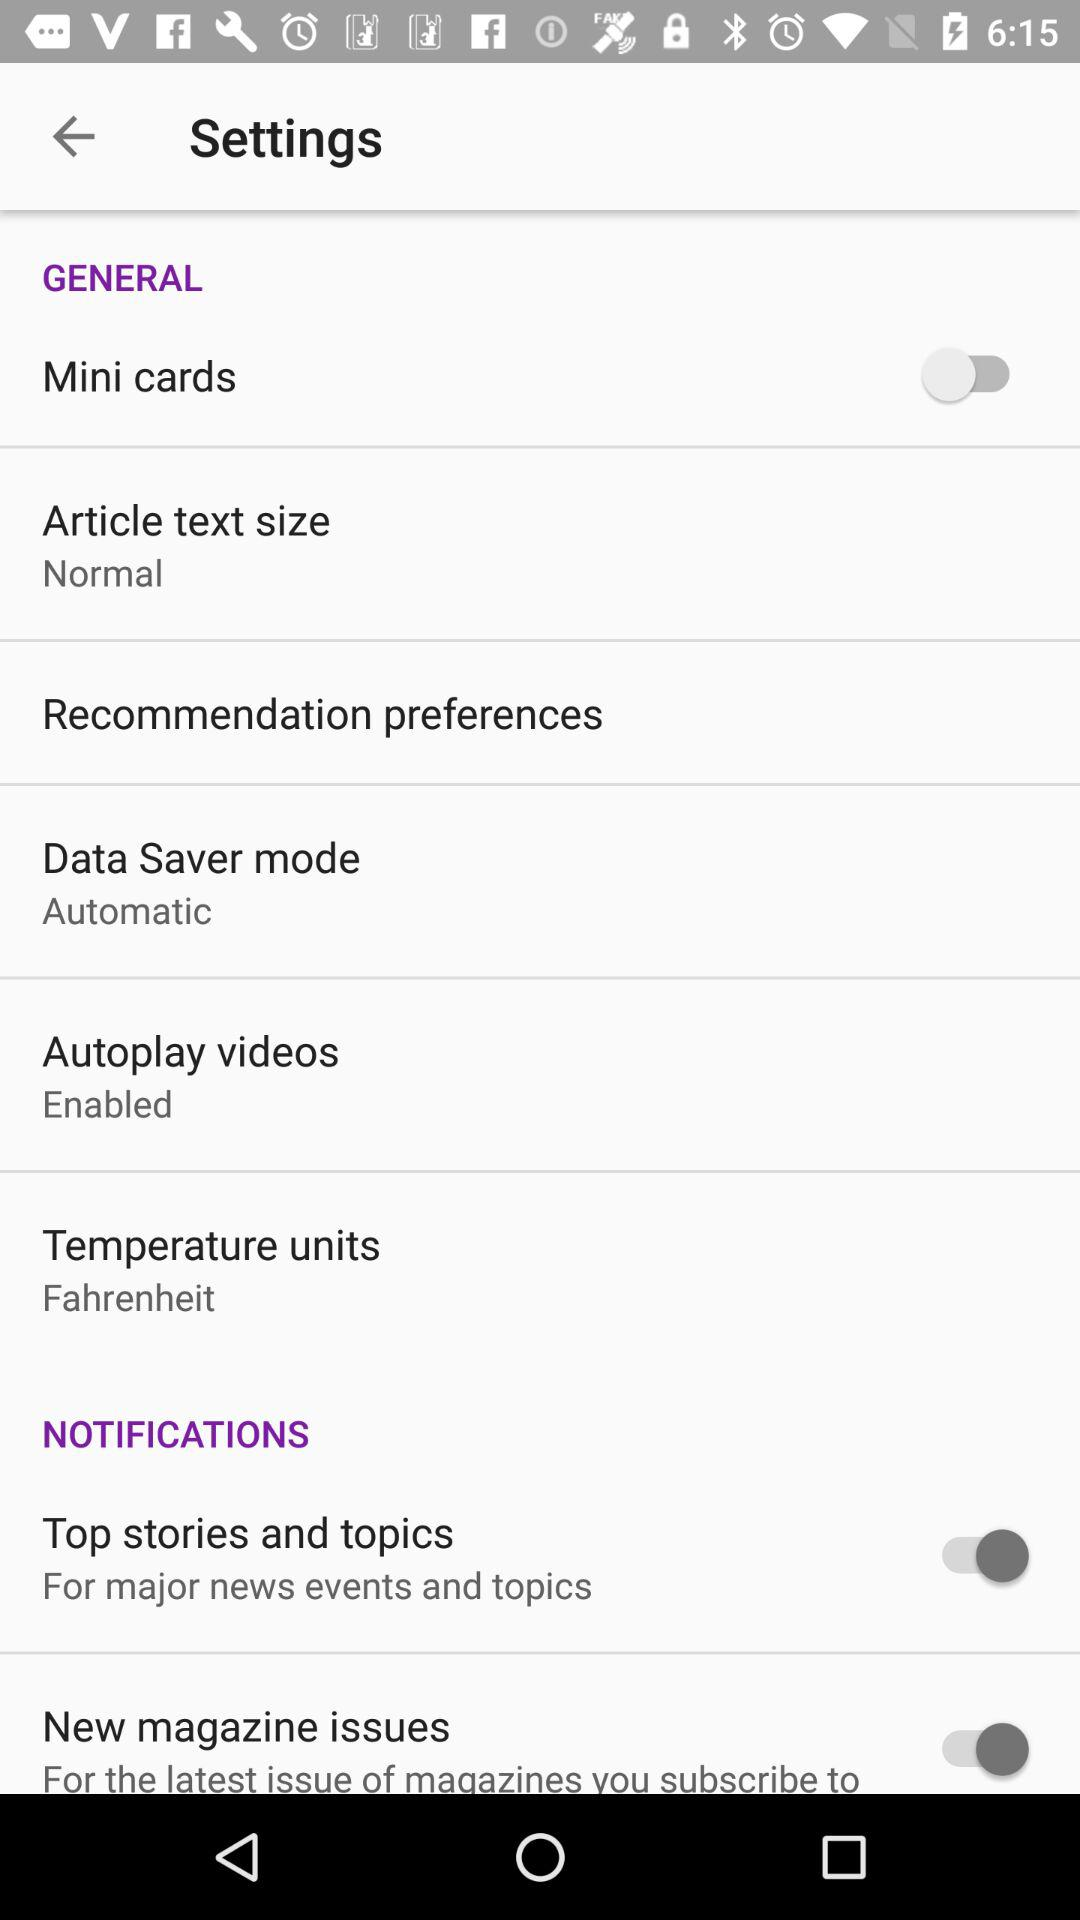What is the status of "Mini cards"? The status is "off". 